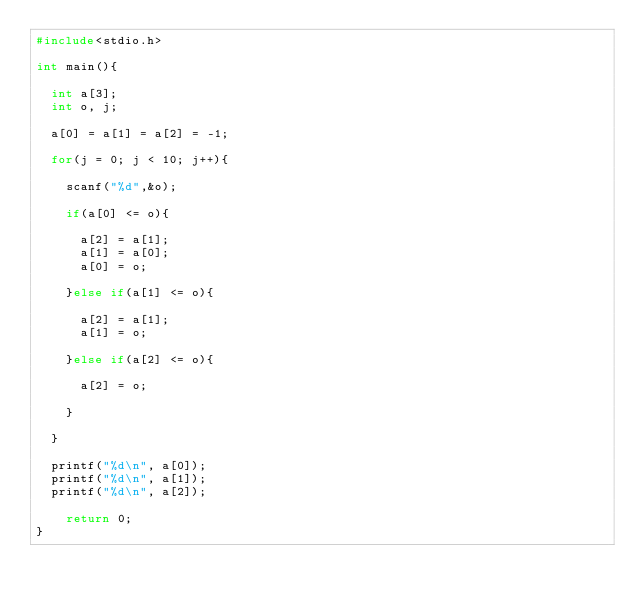<code> <loc_0><loc_0><loc_500><loc_500><_C_>#include<stdio.h>

int main(){
	
	int a[3];
	int o, j;

	a[0] = a[1] = a[2] = -1;
	
	for(j = 0; j < 10; j++){
		
		scanf("%d",&o);
		
		if(a[0] <= o){
			
			a[2] = a[1];
			a[1] = a[0];
			a[0] = o;
			
		}else if(a[1] <= o){
			
			a[2] = a[1];
			a[1] = o;
			
		}else if(a[2] <= o){
			
			a[2] = o;
			
		}
		
	}
	
	printf("%d\n", a[0]);
	printf("%d\n", a[1]);
	printf("%d\n", a[2]);
	
    return 0;
}</code> 